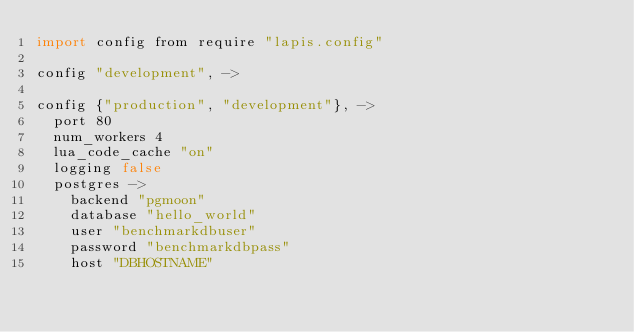<code> <loc_0><loc_0><loc_500><loc_500><_MoonScript_>import config from require "lapis.config"

config "development", ->

config {"production", "development"}, ->
  port 80
  num_workers 4
  lua_code_cache "on"
  logging false
  postgres ->
    backend "pgmoon"
    database "hello_world"
    user "benchmarkdbuser"
    password "benchmarkdbpass"
    host "DBHOSTNAME"
</code> 